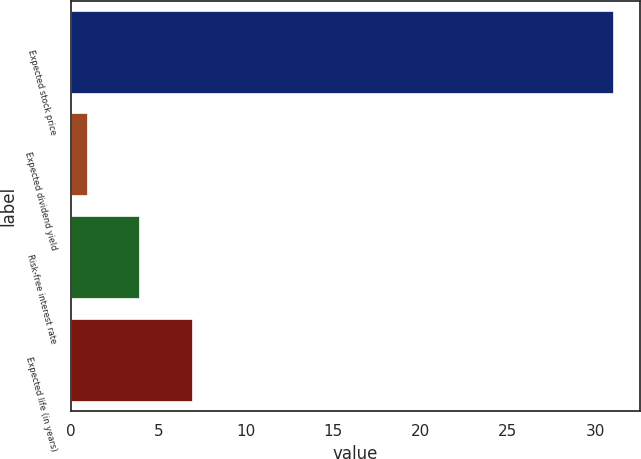Convert chart to OTSL. <chart><loc_0><loc_0><loc_500><loc_500><bar_chart><fcel>Expected stock price<fcel>Expected dividend yield<fcel>Risk-free interest rate<fcel>Expected life (in years)<nl><fcel>31<fcel>0.9<fcel>3.91<fcel>6.92<nl></chart> 